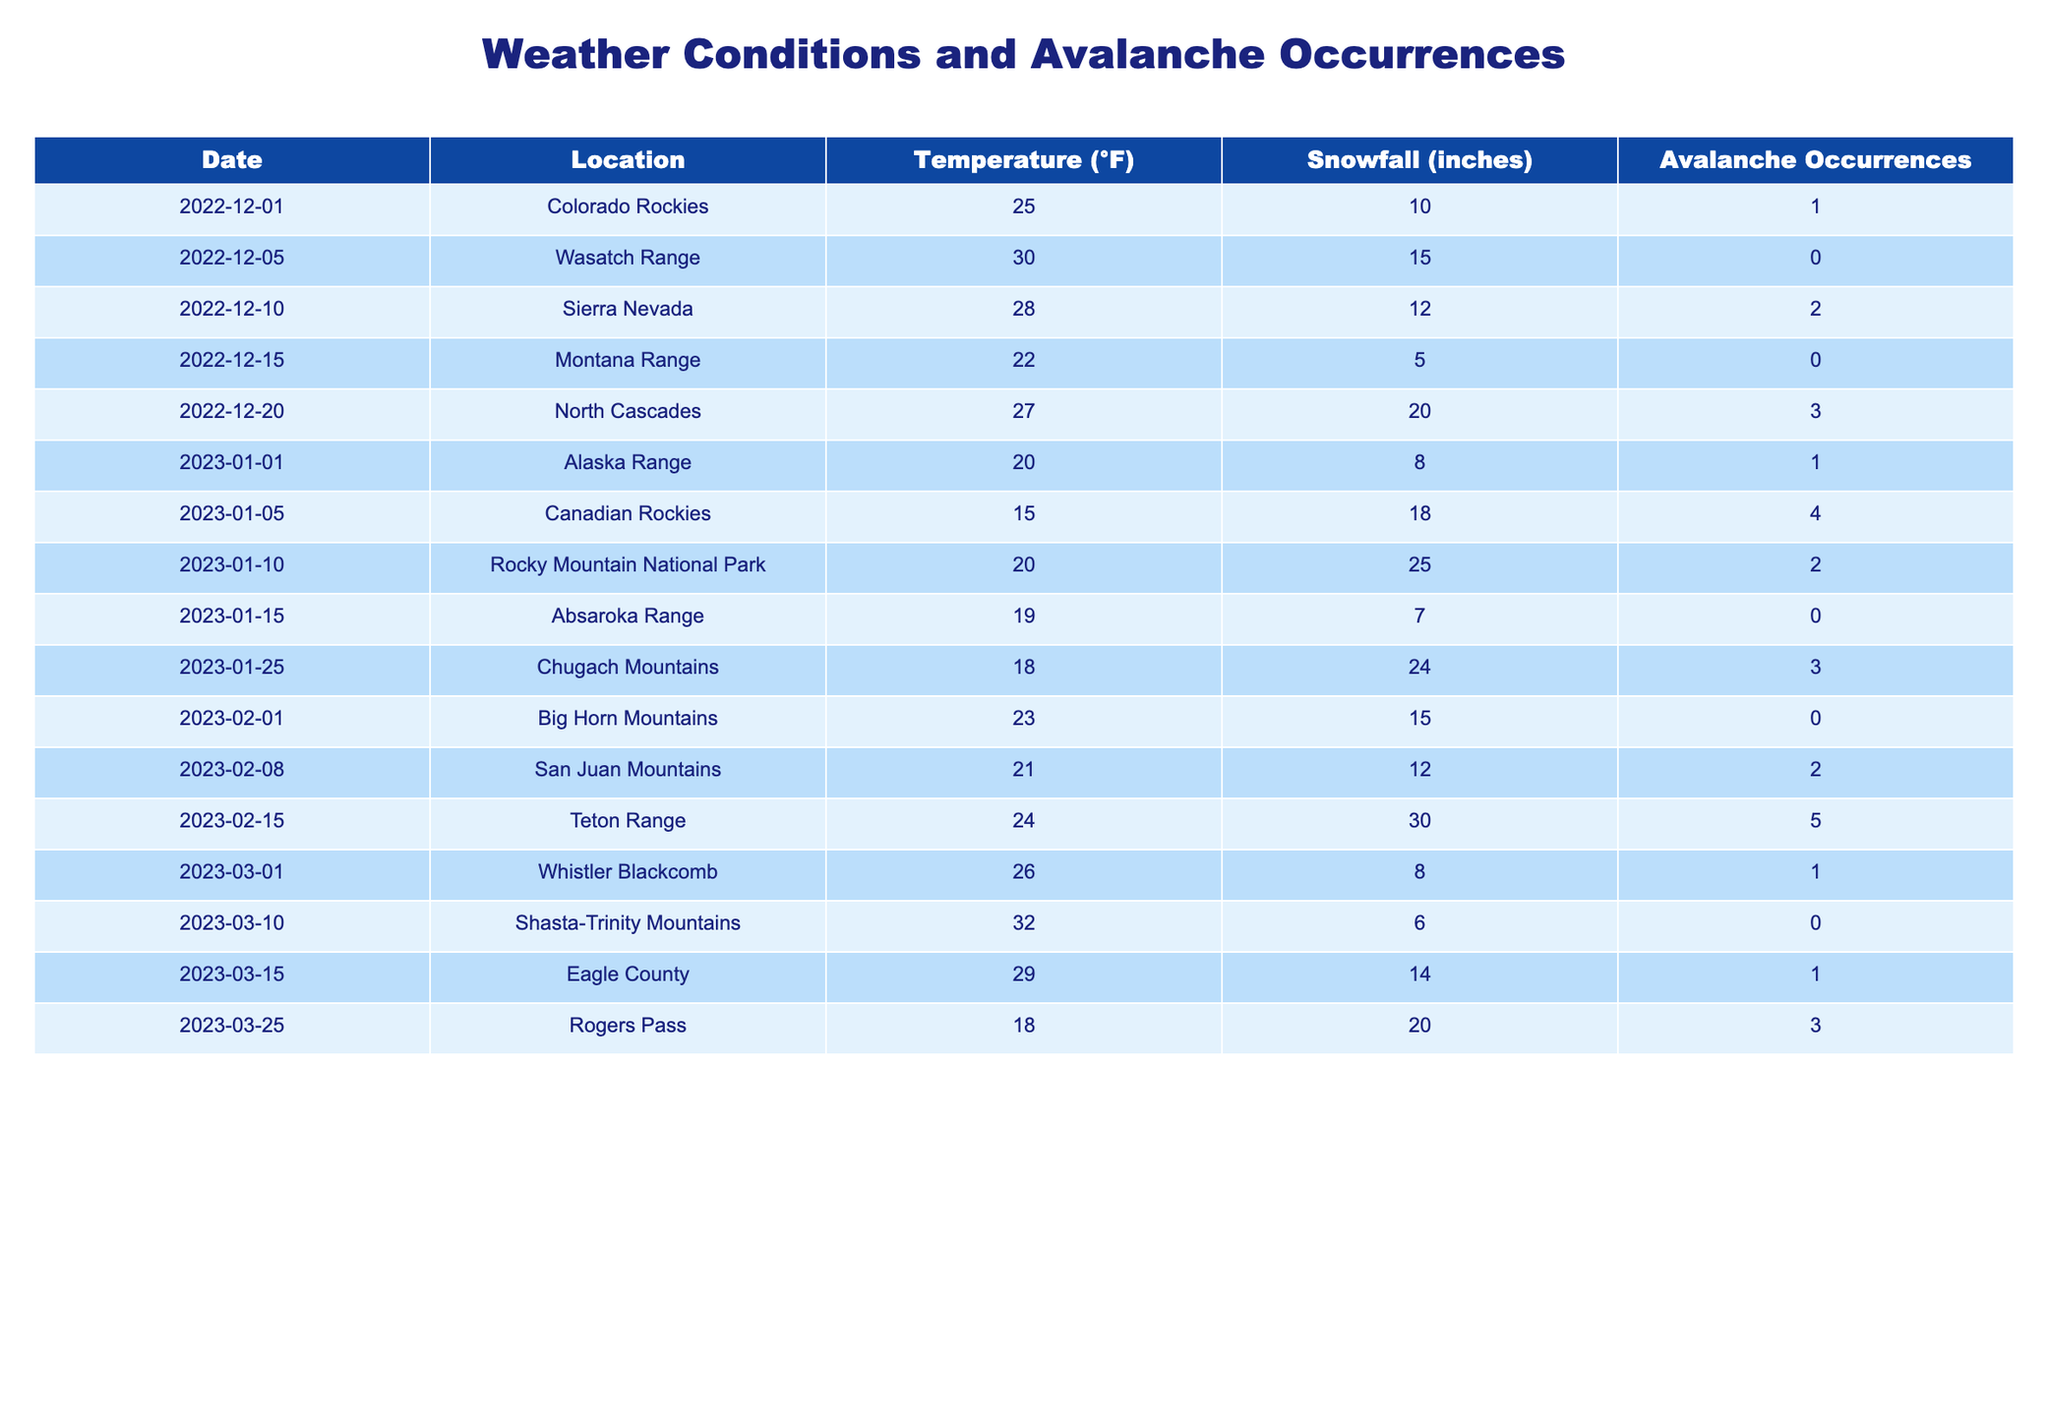What was the highest snowfall recorded in the table? The snowfall values in the table are: 10, 15, 12, 5, 20, 8, 18, 25, 7, 24, 15, 12, 30, 8, 6, 14, 20. The highest value among these is 30 inches recorded on February 15, 2023, at the Teton Range.
Answer: 30 inches How many avalanche occurrences were recorded in the Canadian Rockies? The table shows that there is one entry for the Canadian Rockies on January 5, 2023, with 4 avalanche occurrences. Therefore, the total count for this location is simply taken from that entry.
Answer: 4 What is the average temperature across all locations in the table? The temperature values are: 25, 30, 28, 22, 27, 20, 15, 20, 19, 18, 23, 21, 24, 26, 32, 29, 18. Calculating the sum of these temperatures gives 417°F, and there are 17 entries. Dividing the total temperature by the number of entries gives 417/17 = 24.5°F.
Answer: 24.5°F Did any locations have avalanche occurrences on the same day when snowfall was 20 inches or more? We need to examine the entries for days when snowfall was 20 inches or more: December 20 (20 inches, 3 occurrences), January 5 (18 inches not qualified), January 25 (24 inches, 3 occurrences), and February 15 (30 inches, 5 occurrences). Thus, on December 20, January 25, and February 15, there were avalanche occurrences.
Answer: Yes What is the temperature difference between the warmest and coldest days listed? The warmest recorded temperature is on March 10, 2023, at 32°F, and the coldest is on January 5, 2023, at 15°F. The temperature difference is 32°F - 15°F = 17°F.
Answer: 17°F On how many days were there zero avalanche occurrences? Scanning the table, we find three entries: December 5 (0 occurrences), December 15 (0 occurrences), and January 15 (0 occurrences). Counting these gives us a total of 3 days with zero avalanche occurrences.
Answer: 3 Which location had the most avalanche occurrences recorded, and how many were there? Looking through the table, we see the maximum occurrences listed are at the Teton Range on February 15 with 5 occurrences. Hence, Teton Range is the location with the most occurrences.
Answer: Teton Range, 5 occurrences Is there any location with snowfall less than 10 inches that also recorded avalanche occurrences? Evaluating the table, the only occurrence of snowfall under 10 inches that also had avalanche occurrences is the event on December 1, 2022, with 10 inches and 1 occurrence. Thus, it meets the criteria that snowfall was less than or equal to 10 inches with an avalanche occurrence.
Answer: Yes 